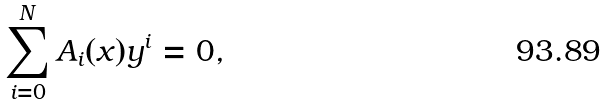Convert formula to latex. <formula><loc_0><loc_0><loc_500><loc_500>\sum _ { i = 0 } ^ { N } A _ { i } ( x ) y ^ { i } = 0 ,</formula> 